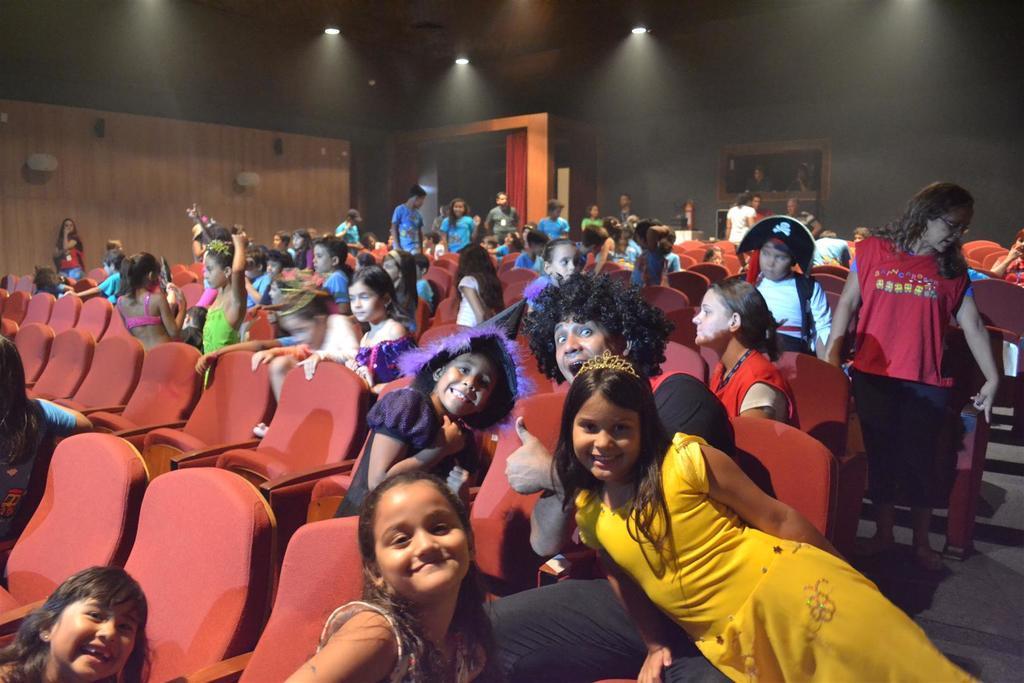Can you describe this image briefly? Here there are few kids and a person sitting on the chairs. In the background there are few people standing,wall,frames on the wall,lights on the roof top,curtain and doors. 